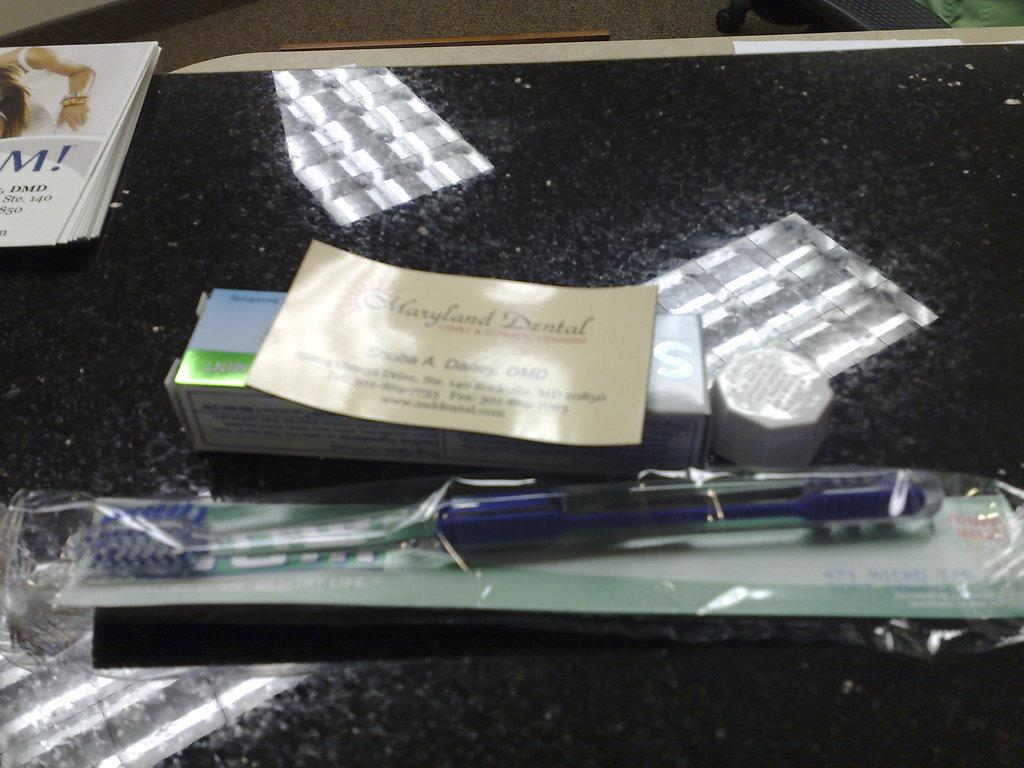What object is protected by a cover in the image? There is a toothbrush in a cover in the image. What type of item contains text in the image? There is a card with text in the image. What container is present in the image? There is a box in the image. What type of material is present on the surface in the image? There are papers on the surface in the image. What type of pet can be seen interacting with the toothbrush in the image? There is no pet present in the image, and therefore no such interaction can be observed. What news event is mentioned on the card in the image? There is no news event mentioned on the card in the image; it only contains text. 